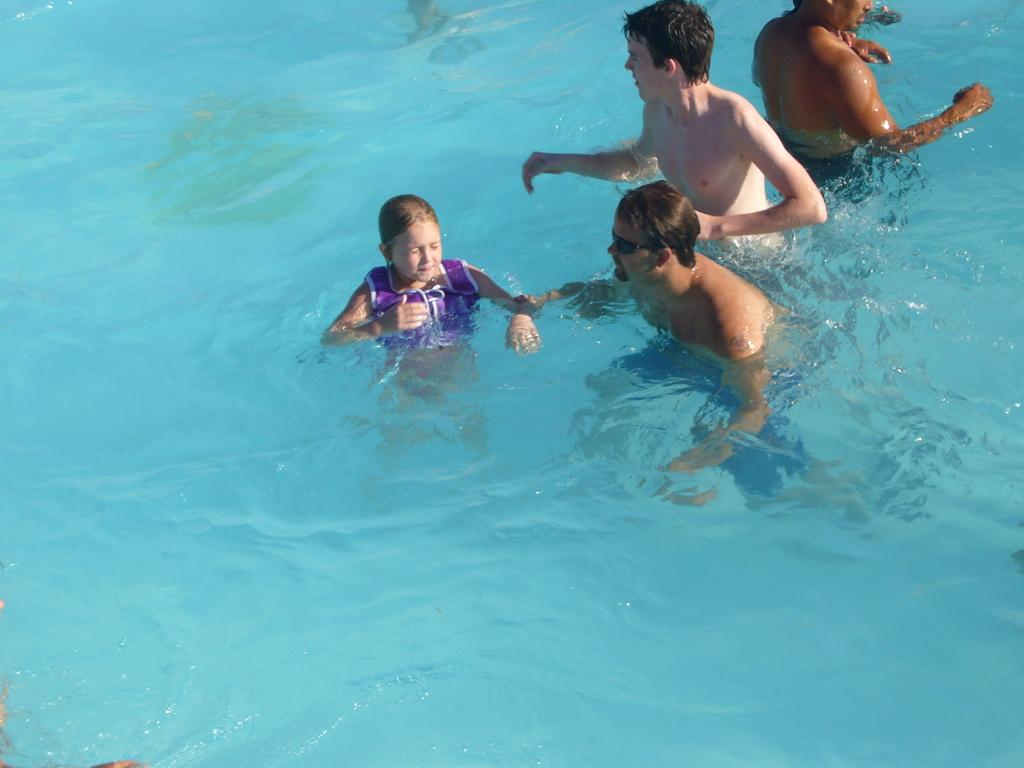What is the primary setting of the image? The primary setting of the image is water. How many people are present in the water? There are four people present in the water: one girl and three men. Can you describe any specific accessory worn by one of the individuals? One person is wearing goggles. What type of eyes can be seen swimming in the water in the image? There are no eyes visible in the water in the image, as eyes are not separate entities that can swim. 